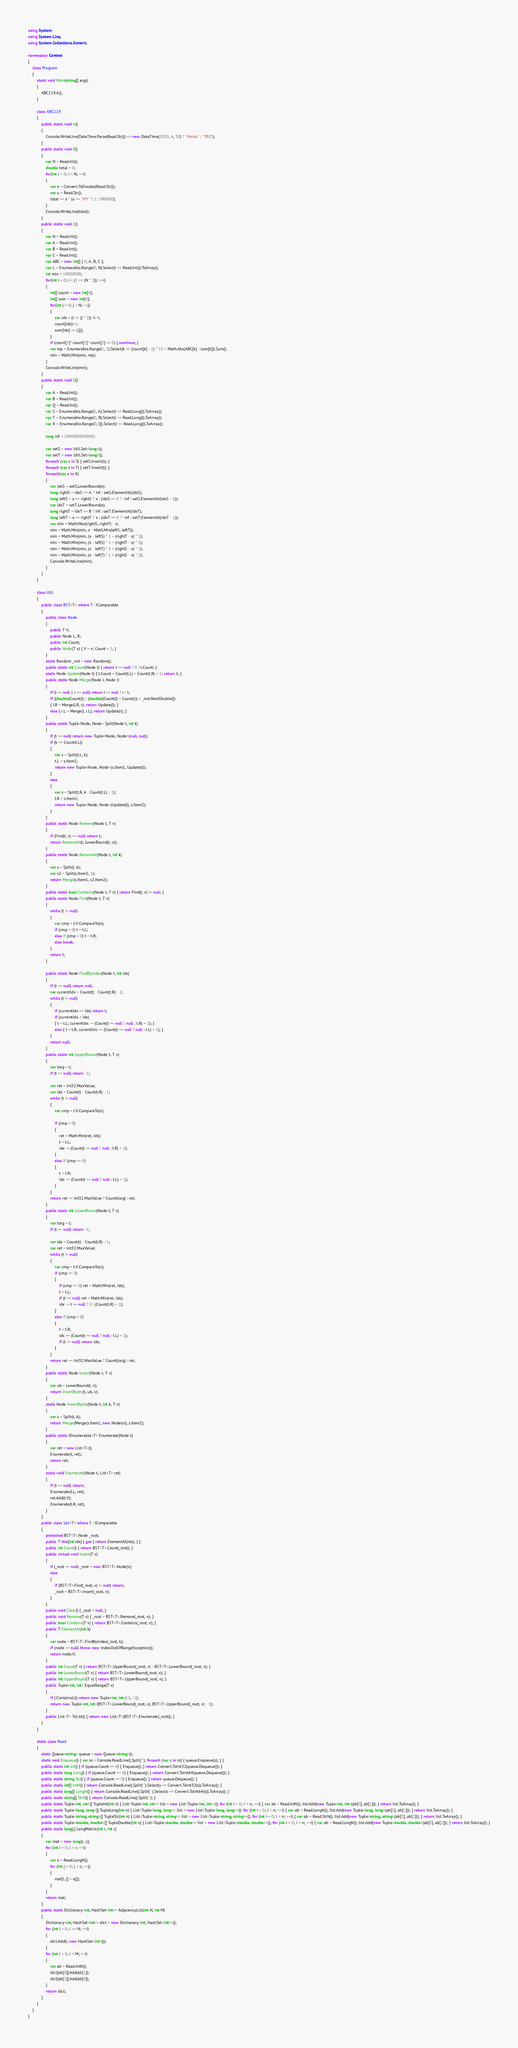Convert code to text. <code><loc_0><loc_0><loc_500><loc_500><_C#_>using System;
using System.Linq;
using System.Collections.Generic;

namespace Contest
{
    class Program
    {
        static void Main(string[] args)
        {
            ABC119.A();
        }

        class ABC119
        {
            public static void A()
            {
                Console.WriteLine(DateTime.Parse(Read.Str()) <= new DateTime(2019, 4, 30) ? "Heisei" : "TBD");
            }
            public static void B()
            {
                var N = Read.Int();
                double total = 0;
                for(int i = 0; i < N; ++i)
                {
                    var x = Convert.ToDouble(Read.Str());
                    var u = Read.Str();
                    total += x * (u == "JPY" ? 1 : 380000);
                }
                Console.WriteLine(total);
            }
            public static void C()
            {
                var N = Read.Int();
                var A = Read.Int();
                var B = Read.Int();
                var C = Read.Int();
                var ABC = new int[] { 0, A, B, C };
                var L = Enumerable.Range(0, N).Select(i => Read.Int()).ToArray();
                int min = 10000000;
                for(int i = 0; i < (1 << (N * 2)); ++i)
                {
                    int[] count = new int[4];
                    int[] sum = new int[4];
                    for(int j = 0; j < N; ++j)
                    {
                        var idx = (i >> (j * 2)) % 4;
                        count[idx]++;
                        sum[idx] += L[j];
                    }
                    if (count[1]* count[2]* count[3] == 0) { continue; }
                    var mp = Enumerable.Range(1, 3).Select(k => (count[k] - 1) * 10 + Math.Abs(ABC[k] - sum[k])).Sum();
                    min = Math.Min(min, mp);
                }
                Console.WriteLine(min);
            }
            public static void D()
            {
                var A = Read.Int();
                var B = Read.Int();
                var Q = Read.Int();
                var S = Enumerable.Range(0, A).Select(i => Read.Long()).ToArray();
                var T = Enumerable.Range(0, B).Select(i => Read.Long()).ToArray();
                var X = Enumerable.Range(0, Q).Select(i => Read.Long()).ToArray();

                long inf = 1000000000000;

                var setS = new Util.Set<long>();
                var setT = new Util.Set<long>();
                foreach (var s in S) { setS.Insert(s); }
                foreach (var t in T) { setT.Insert(t); }
                foreach(var x in X)
                {
                    var idxS = setS.LowerBound(x);
                    long rightS = idxS == A ? inf : setS.ElementAt(idxS);
                    long leftS = x == rightS ? x : (idxS == 0 ? -inf : setS.ElementAt(idxS - 1));
                    var idxT = setT.LowerBound(x);
                    long rightT = idxT == B ? inf : setT.ElementAt(idxT);
                    long leftT = x == rightT ? x : (idxT == 0 ? -inf : setT.ElementAt(idxT - 1));
                    var min = Math.Max(rightS, rightT) - x;
                    min = Math.Min(min, x - Math.Min(leftS, leftT));
                    min = Math.Min(min, (x - leftS) * 2 + (rightT - x) * 1);
                    min = Math.Min(min, (x - leftS) * 1 + (rightT - x) * 2);
                    min = Math.Min(min, (x - leftT) * 2 + (rightS - x) * 1);
                    min = Math.Min(min, (x - leftT) * 1 + (rightS - x) * 2);
                    Console.WriteLine(min);
                }
            }
        }

        class Util
        {
            public class BST<T> where T : IComparable
            {
                public class Node
                {
                    public T V;
                    public Node L, R;
                    public int Count;
                    public Node(T v) { V = v; Count = 1; }
                }
                static Random _rnd = new Random();
                public static int Count(Node t) { return t == null ? 0 : t.Count; }
                static Node Update(Node t) { t.Count = Count(t.L) + Count(t.R) + 1; return t; }
                public static Node Merge(Node l, Node r)
                {
                    if (l == null || r == null) return l == null ? r : l;
                    if ((double)Count(l) / (double)(Count(l) + Count(r)) > _rnd.NextDouble())
                    { l.R = Merge(l.R, r); return Update(l); }
                    else { r.L = Merge(l, r.L); return Update(r); }
                }
                public static Tuple<Node, Node> Split(Node t, int k)
                {
                    if (t == null) return new Tuple<Node, Node>(null, null);
                    if (k <= Count(t.L))
                    {
                        var s = Split(t.L, k);
                        t.L = s.Item2;
                        return new Tuple<Node, Node>(s.Item1, Update(t));
                    }
                    else
                    {
                        var s = Split(t.R, k - Count(t.L) - 1);
                        t.R = s.Item1;
                        return new Tuple<Node, Node>(Update(t), s.Item2);
                    }
                }
                public static Node Remove(Node t, T v)
                {
                    if (Find(t, v) == null) return t;
                    return RemoveAt(t, LowerBound(t, v));
                }
                public static Node RemoveAt(Node t, int k)
                {
                    var s = Split(t, k);
                    var s2 = Split(s.Item2, 1);
                    return Merge(s.Item1, s2.Item2);
                }
                public static bool Contains(Node t, T v) { return Find(t, v) != null; }
                public static Node Find(Node t, T v)
                {
                    while (t != null)
                    {
                        var cmp = t.V.CompareTo(v);
                        if (cmp > 0) t = t.L;
                        else if (cmp < 0) t = t.R;
                        else break;
                    }
                    return t;
                }

                public static Node FindByIndex(Node t, int idx)
                {
                    if (t == null) return null;
                    var currentIdx = Count(t) - Count(t.R) - 1;
                    while (t != null)
                    {
                        if (currentIdx == idx) return t;
                        if (currentIdx > idx)
                        { t = t.L; currentIdx -= (Count(t == null ? null : t.R) + 1); }
                        else { t = t.R; currentIdx += (Count(t == null ? null : t.L) + 1); }
                    }
                    return null;
                }
                public static int UpperBound(Node t, T v)
                {
                    var torg = t;
                    if (t == null) return -1;

                    var ret = Int32.MaxValue;
                    var idx = Count(t) - Count(t.R) - 1;
                    while (t != null)
                    {
                        var cmp = t.V.CompareTo(v);

                        if (cmp > 0)
                        {
                            ret = Math.Min(ret, idx);
                            t = t.L;
                            idx -= (Count(t == null ? null : t.R) + 1);
                        }
                        else if (cmp <= 0)
                        {
                            t = t.R;
                            idx += (Count(t == null ? null : t.L) + 1);
                        }
                    }
                    return ret == Int32.MaxValue ? Count(torg) : ret;
                }
                public static int LowerBound(Node t, T v)
                {
                    var torg = t;
                    if (t == null) return -1;

                    var idx = Count(t) - Count(t.R) - 1;
                    var ret = Int32.MaxValue;
                    while (t != null)
                    {
                        var cmp = t.V.CompareTo(v);
                        if (cmp >= 0)
                        {
                            if (cmp == 0) ret = Math.Min(ret, idx);
                            t = t.L;
                            if (t == null) ret = Math.Min(ret, idx);
                            idx -= t == null ? 0 : (Count(t.R) + 1);
                        }
                        else if (cmp < 0)
                        {
                            t = t.R;
                            idx += (Count(t == null ? null : t.L) + 1);
                            if (t == null) return idx;
                        }
                    }
                    return ret == Int32.MaxValue ? Count(torg) : ret;
                }
                public static Node Insert(Node t, T v)
                {
                    var ub = LowerBound(t, v);
                    return InsertByIdx(t, ub, v);
                }
                static Node InsertByIdx(Node t, int k, T v)
                {
                    var s = Split(t, k);
                    return Merge(Merge(s.Item1, new Node(v)), s.Item2);
                }
                public static IEnumerable<T> Enumerate(Node t)
                {
                    var ret = new List<T>();
                    Enumerate(t, ret);
                    return ret;
                }
                static void Enumerate(Node t, List<T> ret)
                {
                    if (t == null) return;
                    Enumerate(t.L, ret);
                    ret.Add(t.V);
                    Enumerate(t.R, ret);
                }
            }
            public class Set<T> where T : IComparable
            {
                protected BST<T>.Node _root;
                public T this[int idx] { get { return ElementAt(idx); } }
                public int Count() { return BST<T>.Count(_root); }
                public virtual void Insert(T v)
                {
                    if (_root == null) _root = new BST<T>.Node(v);
                    else
                    {
                        if (BST<T>.Find(_root, v) != null) return;
                        _root = BST<T>.Insert(_root, v);
                    }
                }
                public void Clear() { _root = null; }
                public void Remove(T v) { _root = BST<T>.Remove(_root, v); }
                public bool Contains(T v) { return BST<T>.Contains(_root, v); }
                public T ElementAt(int k)
                {
                    var node = BST<T>.FindByIndex(_root, k);
                    if (node == null) throw new IndexOutOfRangeException();
                    return node.V;
                }
                public int Count(T v) { return BST<T>.UpperBound(_root, v) - BST<T>.LowerBound(_root, v); }
                public int LowerBound(T v) { return BST<T>.LowerBound(_root, v); }
                public int UpperBound(T v) { return BST<T>.UpperBound(_root, v); }
                public Tuple<int, int> EqualRange(T v)
                {
                    if (!Contains(v)) return new Tuple<int, int>(-1, -1);
                    return new Tuple<int, int>(BST<T>.LowerBound(_root, v), BST<T>.UpperBound(_root, v) - 1);
                }
                public List<T> ToList() { return new List<T>(BST<T>.Enumerate(_root)); }
            }
        }

        static class Read
        {
            static Queue<string> queue = new Queue<string>();
            static void Enqueue() { var ss = Console.ReadLine().Split(' '); foreach (var s in ss) { queue.Enqueue(s); } }
            public static int Int() { if (queue.Count == 0) { Enqueue(); } return Convert.ToInt32(queue.Dequeue()); }
            public static long Long() { if (queue.Count == 0) { Enqueue(); } return Convert.ToInt64(queue.Dequeue()); }
            public static string Str() { if (queue.Count == 0) { Enqueue(); } return queue.Dequeue(); }
            public static int[] IntN() { return Console.ReadLine().Split(' ').Select(s => Convert.ToInt32(s)).ToArray(); }
            public static long[] LongN() { return Console.ReadLine().Split(' ').Select(s => Convert.ToInt64(s)).ToArray(); }
            public static string[] StrN() { return Console.ReadLine().Split(' '); }
            public static Tuple<int, int>[] TupleInt(int n) { List<Tuple<int, int>> list = new List<Tuple<int, int>>(); for (int i = 0; i < n; ++i) { var ab = Read.IntN(); list.Add(new Tuple<int, int>(ab[0], ab[1])); } return list.ToArray(); }
            public static Tuple<long, long>[] TupleLong(int n) { List<Tuple<long, long>> list = new List<Tuple<long, long>>(); for (int i = 0; i < n; ++i) { var ab = Read.LongN(); list.Add(new Tuple<long, long>(ab[0], ab[1])); } return list.ToArray(); }
            public static Tuple<string, string>[] TupleStr(int n) { List<Tuple<string, string>> list = new List<Tuple<string, string>>(); for (int i = 0; i < n; ++i) { var ab = Read.StrN(); list.Add(new Tuple<string, string>(ab[0], ab[1])); } return list.ToArray(); }
            public static Tuple<double, double>[] TupleDouble(int n) { List<Tuple<double, double>> list = new List<Tuple<double, double>>(); for (int i = 0; i < n; ++i) { var ab = Read.LongN(); list.Add(new Tuple<double, double>(ab[0], ab[1])); } return list.ToArray(); }
            public static long[,] LongMatrix(int r, int c)
            {
                var mat = new long[r, c];
                for (int i = 0; i < r; ++i)
                {
                    var x = Read.LongN();
                    for (int j = 0; j < c; ++j)
                    {
                        mat[i, j] = x[j];
                    }
                }
                return mat;
            }
            public static Dictionary<int, HashSet<int>> AdjacencyList(int N, int M)
            {
                Dictionary<int, HashSet<int>> dict = new Dictionary<int, HashSet<int>>();
                for (int i = 0; i <= N; ++i)
                {
                    dict.Add(i, new HashSet<int>());
                }
                for (int i = 0; i < M; ++i)
                {
                    var ab = Read.IntN();
                    dict[ab[0]].Add(ab[1]);
                    dict[ab[1]].Add(ab[0]);
                }
                return dict;
            }
        }
    }
}
</code> 